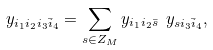<formula> <loc_0><loc_0><loc_500><loc_500>y _ { i _ { 1 } i _ { 2 } i _ { 3 } \bar { i } _ { 4 } } = \sum _ { s \in Z _ { M } } y _ { i _ { 1 } i _ { 2 } \bar { s } } \ y _ { s i _ { 3 } \bar { i } _ { 4 } } ,</formula> 